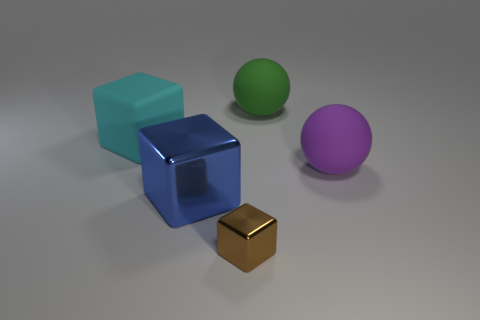Is the big cube in front of the large cyan block made of the same material as the small brown block?
Offer a very short reply. Yes. Are there an equal number of big cyan matte cubes that are behind the big blue metallic block and gray cubes?
Your answer should be very brief. No. The green thing is what size?
Provide a succinct answer. Large. What number of big cubes have the same color as the tiny cube?
Offer a very short reply. 0. Do the green sphere and the blue metallic cube have the same size?
Give a very brief answer. Yes. What size is the rubber sphere that is behind the big rubber ball that is in front of the cyan matte block?
Ensure brevity in your answer.  Large. Do the big metal thing and the matte thing on the left side of the brown metal block have the same color?
Ensure brevity in your answer.  No. Are there any matte things of the same size as the brown shiny cube?
Provide a short and direct response. No. There is a metal cube left of the small brown metal thing; what is its size?
Your answer should be very brief. Large. Is there a tiny brown object behind the matte sphere behind the large cyan matte cube?
Provide a short and direct response. No. 